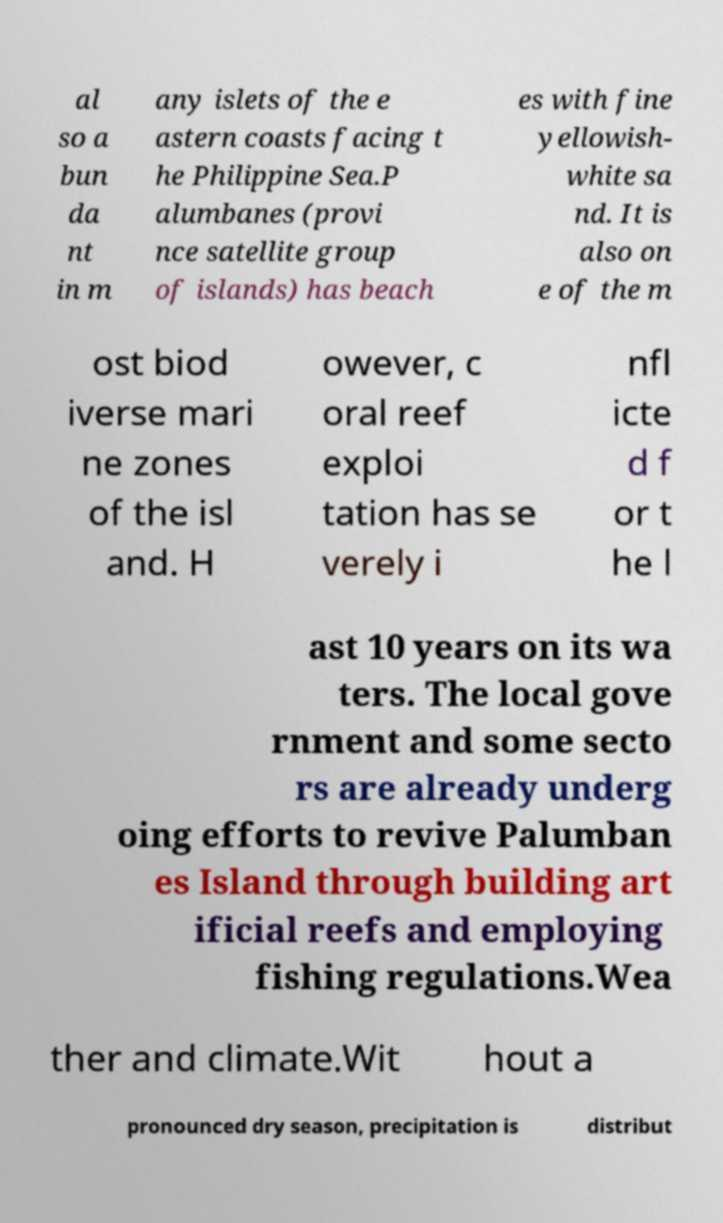I need the written content from this picture converted into text. Can you do that? al so a bun da nt in m any islets of the e astern coasts facing t he Philippine Sea.P alumbanes (provi nce satellite group of islands) has beach es with fine yellowish- white sa nd. It is also on e of the m ost biod iverse mari ne zones of the isl and. H owever, c oral reef exploi tation has se verely i nfl icte d f or t he l ast 10 years on its wa ters. The local gove rnment and some secto rs are already underg oing efforts to revive Palumban es Island through building art ificial reefs and employing fishing regulations.Wea ther and climate.Wit hout a pronounced dry season, precipitation is distribut 